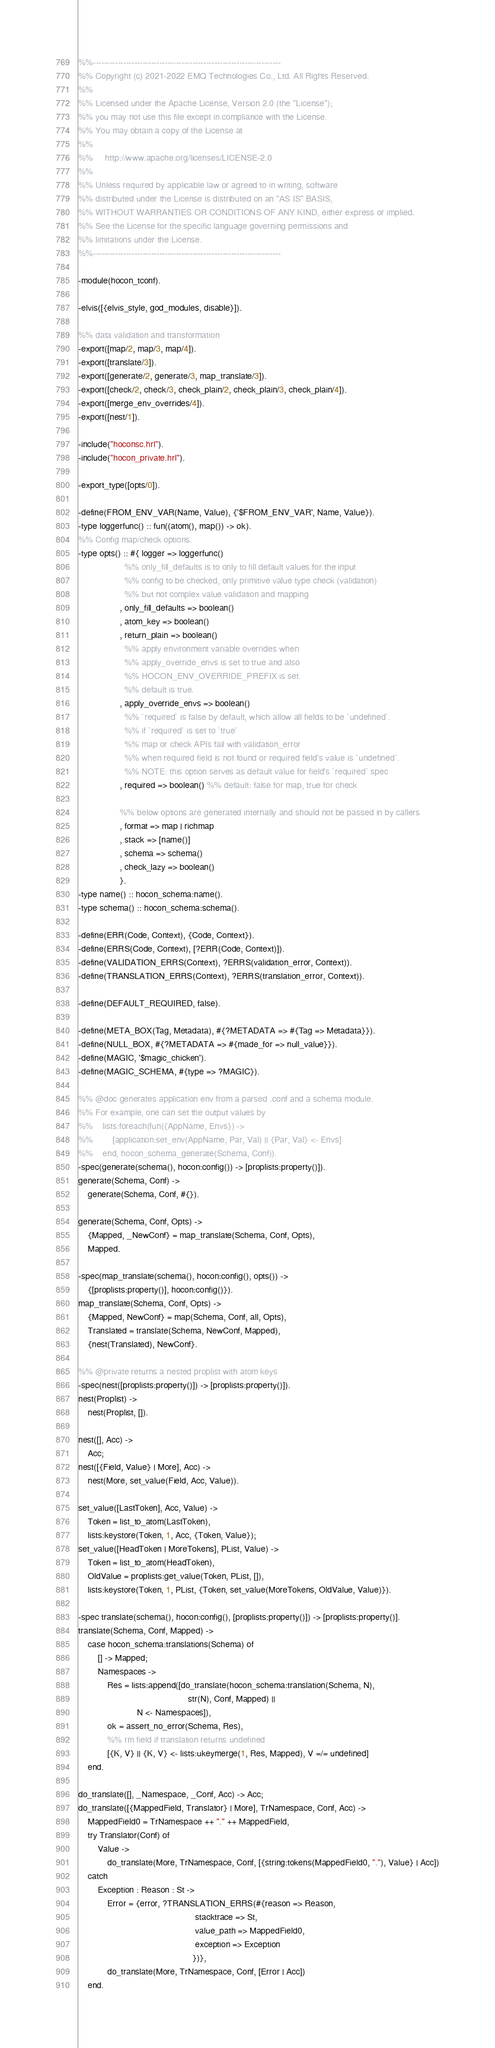<code> <loc_0><loc_0><loc_500><loc_500><_Erlang_>%%--------------------------------------------------------------------
%% Copyright (c) 2021-2022 EMQ Technologies Co., Ltd. All Rights Reserved.
%%
%% Licensed under the Apache License, Version 2.0 (the "License");
%% you may not use this file except in compliance with the License.
%% You may obtain a copy of the License at
%%
%%     http://www.apache.org/licenses/LICENSE-2.0
%%
%% Unless required by applicable law or agreed to in writing, software
%% distributed under the License is distributed on an "AS IS" BASIS,
%% WITHOUT WARRANTIES OR CONDITIONS OF ANY KIND, either express or implied.
%% See the License for the specific language governing permissions and
%% limitations under the License.
%%--------------------------------------------------------------------

-module(hocon_tconf).

-elvis([{elvis_style, god_modules, disable}]).

%% data validation and transformation
-export([map/2, map/3, map/4]).
-export([translate/3]).
-export([generate/2, generate/3, map_translate/3]).
-export([check/2, check/3, check_plain/2, check_plain/3, check_plain/4]).
-export([merge_env_overrides/4]).
-export([nest/1]).

-include("hoconsc.hrl").
-include("hocon_private.hrl").

-export_type([opts/0]).

-define(FROM_ENV_VAR(Name, Value), {'$FROM_ENV_VAR', Name, Value}).
-type loggerfunc() :: fun((atom(), map()) -> ok).
%% Config map/check options.
-type opts() :: #{ logger => loggerfunc()
                   %% only_fill_defaults is to only to fill default values for the input
                   %% config to be checked, only primitive value type check (validation)
                   %% but not complex value validation and mapping
                 , only_fill_defaults => boolean()
                 , atom_key => boolean()
                 , return_plain => boolean()
                   %% apply environment variable overrides when
                   %% apply_override_envs is set to true and also
                   %% HOCON_ENV_OVERRIDE_PREFIX is set.
                   %% default is true.
                 , apply_override_envs => boolean()
                   %% `required` is false by default, which allow all fields to be `undefined`.
                   %% if `required` is set to `true`
                   %% map or check APIs fail with validation_error
                   %% when required field is not found or required field's value is `undefined`.
                   %% NOTE: this option serves as default value for field's `required` spec
                 , required => boolean() %% default: false for map, true for check

                 %% below options are generated internally and should not be passed in by callers
                 , format => map | richmap
                 , stack => [name()]
                 , schema => schema()
                 , check_lazy => boolean()
                 }.
-type name() :: hocon_schema:name().
-type schema() :: hocon_schema:schema().

-define(ERR(Code, Context), {Code, Context}).
-define(ERRS(Code, Context), [?ERR(Code, Context)]).
-define(VALIDATION_ERRS(Context), ?ERRS(validation_error, Context)).
-define(TRANSLATION_ERRS(Context), ?ERRS(translation_error, Context)).

-define(DEFAULT_REQUIRED, false).

-define(META_BOX(Tag, Metadata), #{?METADATA => #{Tag => Metadata}}).
-define(NULL_BOX, #{?METADATA => #{made_for => null_value}}).
-define(MAGIC, '$magic_chicken').
-define(MAGIC_SCHEMA, #{type => ?MAGIC}).

%% @doc generates application env from a parsed .conf and a schema module.
%% For example, one can set the output values by
%%    lists:foreach(fun({AppName, Envs}) ->
%%        [application:set_env(AppName, Par, Val) || {Par, Val} <- Envs]
%%    end, hocon_schema_generate(Schema, Conf)).
-spec(generate(schema(), hocon:config()) -> [proplists:property()]).
generate(Schema, Conf) ->
    generate(Schema, Conf, #{}).

generate(Schema, Conf, Opts) ->
    {Mapped, _NewConf} = map_translate(Schema, Conf, Opts),
    Mapped.

-spec(map_translate(schema(), hocon:config(), opts()) ->
    {[proplists:property()], hocon:config()}).
map_translate(Schema, Conf, Opts) ->
    {Mapped, NewConf} = map(Schema, Conf, all, Opts),
    Translated = translate(Schema, NewConf, Mapped),
    {nest(Translated), NewConf}.

%% @private returns a nested proplist with atom keys
-spec(nest([proplists:property()]) -> [proplists:property()]).
nest(Proplist) ->
    nest(Proplist, []).

nest([], Acc) ->
    Acc;
nest([{Field, Value} | More], Acc) ->
    nest(More, set_value(Field, Acc, Value)).

set_value([LastToken], Acc, Value) ->
    Token = list_to_atom(LastToken),
    lists:keystore(Token, 1, Acc, {Token, Value});
set_value([HeadToken | MoreTokens], PList, Value) ->
    Token = list_to_atom(HeadToken),
    OldValue = proplists:get_value(Token, PList, []),
    lists:keystore(Token, 1, PList, {Token, set_value(MoreTokens, OldValue, Value)}).

-spec translate(schema(), hocon:config(), [proplists:property()]) -> [proplists:property()].
translate(Schema, Conf, Mapped) ->
    case hocon_schema:translations(Schema) of
        [] -> Mapped;
        Namespaces ->
            Res = lists:append([do_translate(hocon_schema:translation(Schema, N),
                                             str(N), Conf, Mapped) ||
                        N <- Namespaces]),
            ok = assert_no_error(Schema, Res),
            %% rm field if translation returns undefined
            [{K, V} || {K, V} <- lists:ukeymerge(1, Res, Mapped), V =/= undefined]
    end.

do_translate([], _Namespace, _Conf, Acc) -> Acc;
do_translate([{MappedField, Translator} | More], TrNamespace, Conf, Acc) ->
    MappedField0 = TrNamespace ++ "." ++ MappedField,
    try Translator(Conf) of
        Value ->
            do_translate(More, TrNamespace, Conf, [{string:tokens(MappedField0, "."), Value} | Acc])
    catch
        Exception : Reason : St ->
            Error = {error, ?TRANSLATION_ERRS(#{reason => Reason,
                                                stacktrace => St,
                                                value_path => MappedField0,
                                                exception => Exception
                                               })},
            do_translate(More, TrNamespace, Conf, [Error | Acc])
    end.
</code> 